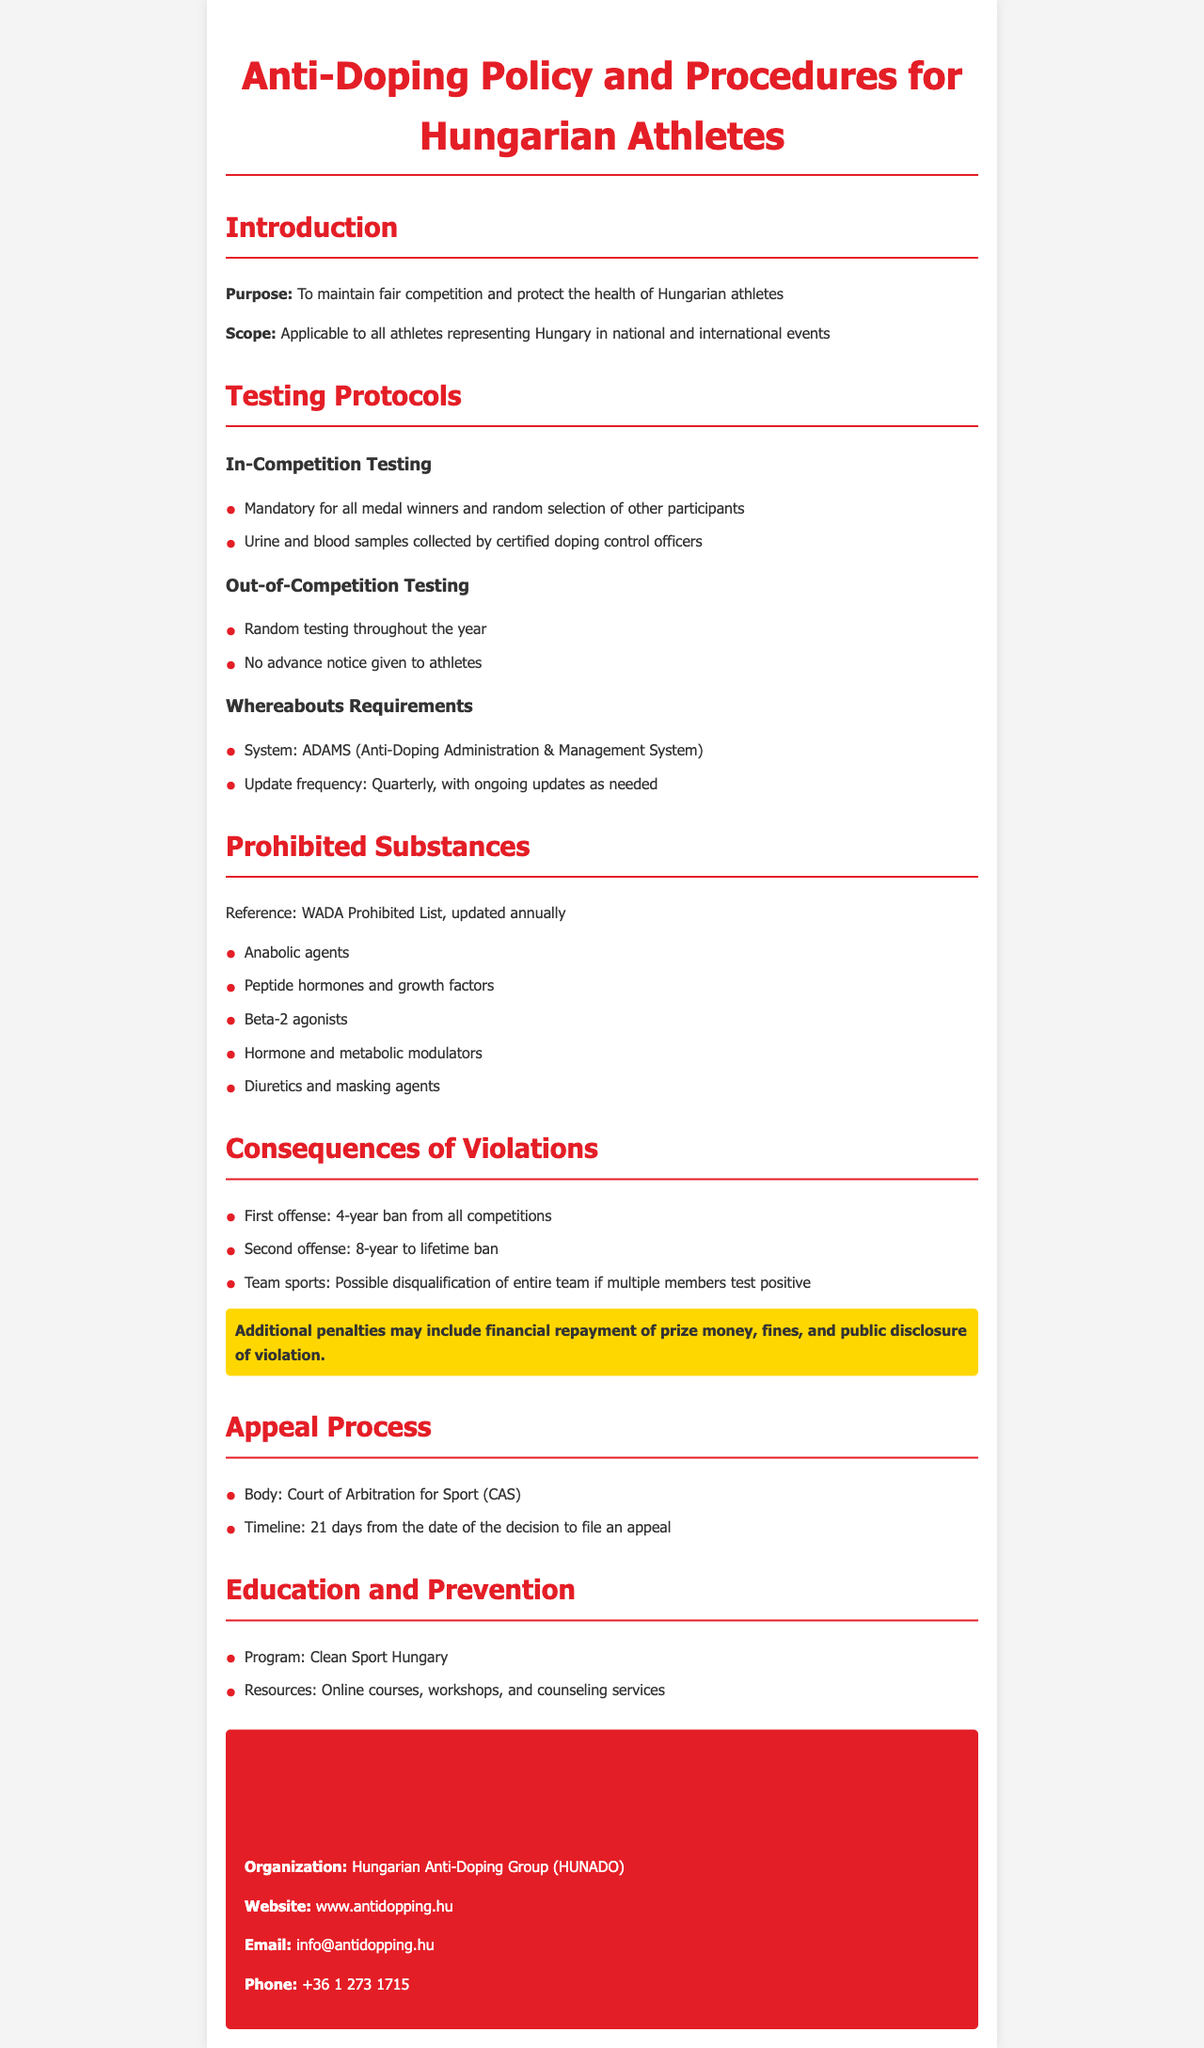What is the purpose of the Anti-Doping Policy? The purpose is to maintain fair competition and protect the health of Hungarian athletes.
Answer: To maintain fair competition and protect the health of Hungarian athletes What system is used for Whereabouts Requirements? The document specifies the system used for Whereabouts Requirements.
Answer: ADAMS What is the consequence of a first offense? The document outlines the consequence for a first doping offense.
Answer: 4-year ban from all competitions How often should athletes update their whereabouts? The document indicates the frequency of updates required.
Answer: Quarterly What is the name of the anti-doping education program? The program aimed at education and prevention is mentioned in the document.
Answer: Clean Sport Hungary What can happen to an entire team if multiple members test positive? The document discusses possible consequences for team sports in such cases.
Answer: Possible disqualification of entire team What is the timeline to file an appeal? The document states the length of time available to file an appeal.
Answer: 21 days How long is the ban for a second offense? The document details the duration of the ban for a second doping violation.
Answer: 8-year to lifetime ban 